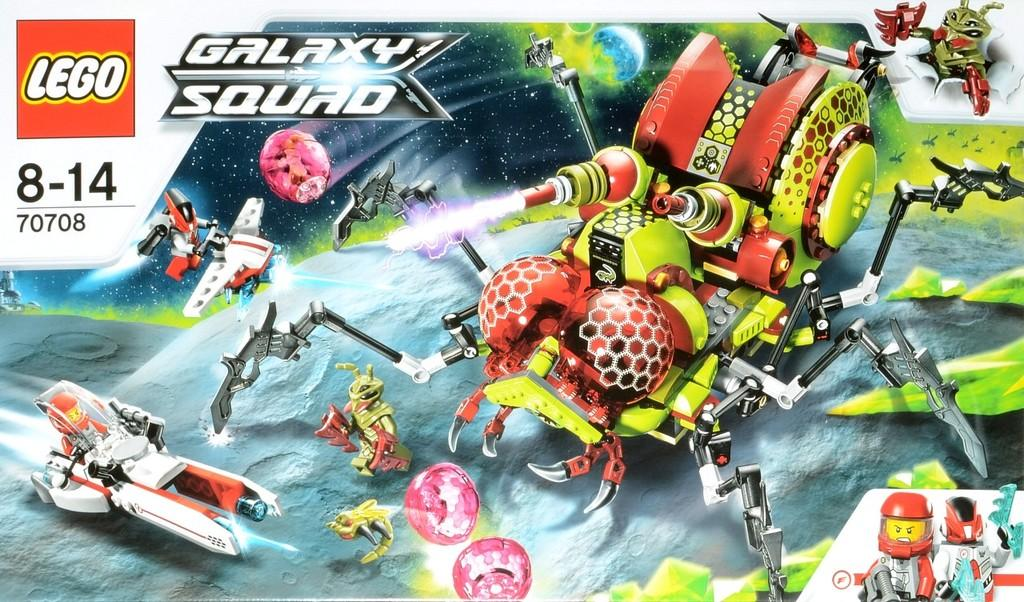What type of image is depicted in the poster? The image is a poster. What kind of toys are featured in the poster? There are lego toys in the poster. What style of images are present in the poster? There are animated images in the poster. Can you see a parent attempting to fight with the lego toys in the poster? There is no parent or fighting depicted in the poster; it features lego toys and animated images. 